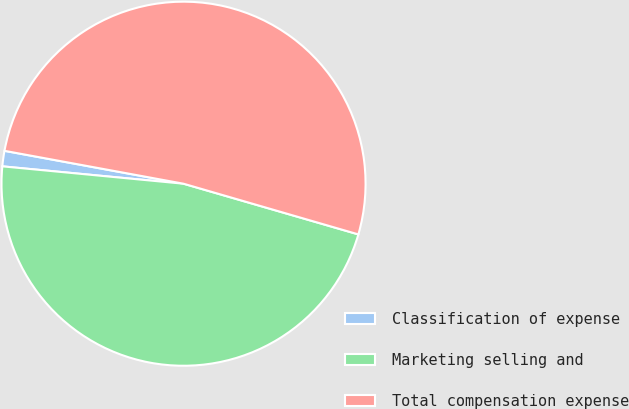Convert chart to OTSL. <chart><loc_0><loc_0><loc_500><loc_500><pie_chart><fcel>Classification of expense<fcel>Marketing selling and<fcel>Total compensation expense<nl><fcel>1.37%<fcel>47.03%<fcel>51.6%<nl></chart> 